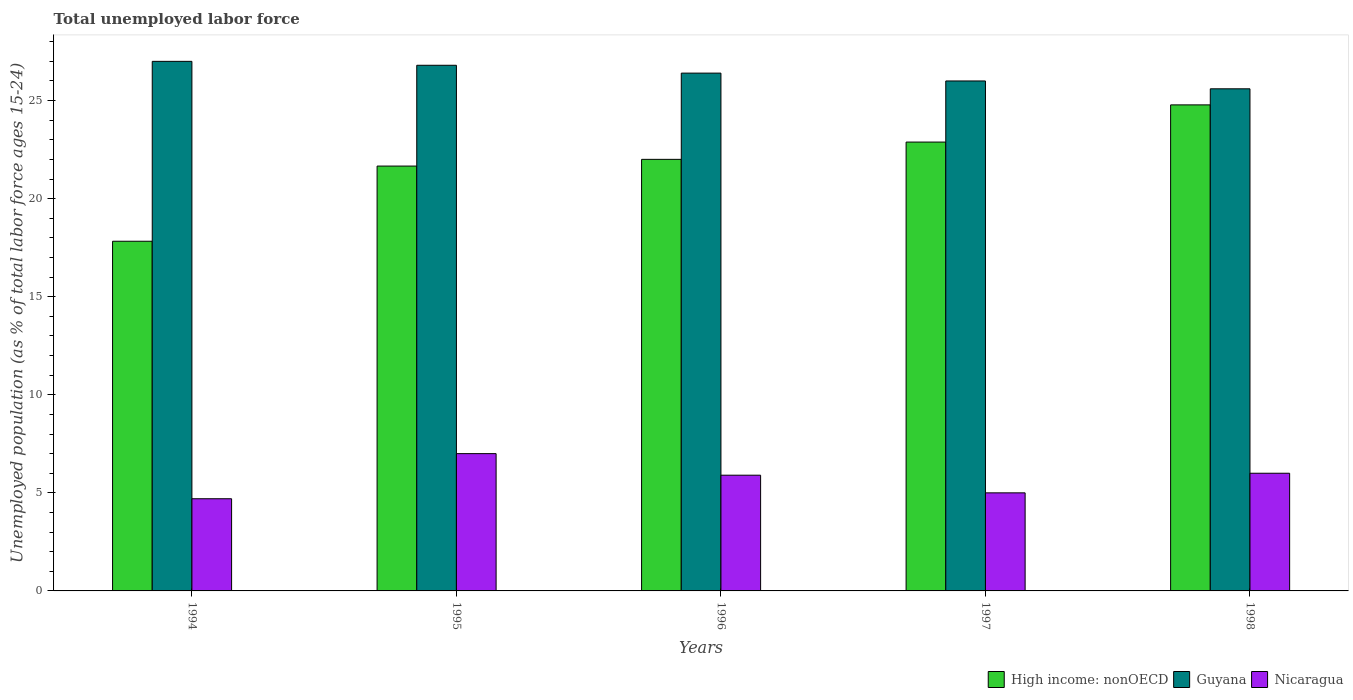How many different coloured bars are there?
Your response must be concise. 3. Are the number of bars per tick equal to the number of legend labels?
Keep it short and to the point. Yes. Are the number of bars on each tick of the X-axis equal?
Your answer should be very brief. Yes. How many bars are there on the 3rd tick from the left?
Your answer should be very brief. 3. In how many cases, is the number of bars for a given year not equal to the number of legend labels?
Offer a terse response. 0. What is the percentage of unemployed population in in High income: nonOECD in 1996?
Your answer should be compact. 22. Across all years, what is the maximum percentage of unemployed population in in High income: nonOECD?
Offer a terse response. 24.78. Across all years, what is the minimum percentage of unemployed population in in High income: nonOECD?
Make the answer very short. 17.83. In which year was the percentage of unemployed population in in High income: nonOECD minimum?
Your response must be concise. 1994. What is the total percentage of unemployed population in in Nicaragua in the graph?
Your answer should be compact. 28.6. What is the difference between the percentage of unemployed population in in High income: nonOECD in 1995 and that in 1998?
Offer a terse response. -3.12. What is the difference between the percentage of unemployed population in in High income: nonOECD in 1998 and the percentage of unemployed population in in Guyana in 1996?
Offer a very short reply. -1.62. What is the average percentage of unemployed population in in High income: nonOECD per year?
Provide a succinct answer. 21.83. In the year 1998, what is the difference between the percentage of unemployed population in in Guyana and percentage of unemployed population in in Nicaragua?
Your answer should be compact. 19.6. What is the ratio of the percentage of unemployed population in in Guyana in 1994 to that in 1998?
Your answer should be very brief. 1.05. What is the difference between the highest and the second highest percentage of unemployed population in in Guyana?
Make the answer very short. 0.2. What is the difference between the highest and the lowest percentage of unemployed population in in Guyana?
Offer a very short reply. 1.4. Is the sum of the percentage of unemployed population in in Guyana in 1994 and 1996 greater than the maximum percentage of unemployed population in in Nicaragua across all years?
Offer a very short reply. Yes. What does the 3rd bar from the left in 1995 represents?
Provide a short and direct response. Nicaragua. What does the 2nd bar from the right in 1995 represents?
Your answer should be compact. Guyana. How many bars are there?
Offer a very short reply. 15. Are all the bars in the graph horizontal?
Give a very brief answer. No. What is the difference between two consecutive major ticks on the Y-axis?
Provide a short and direct response. 5. Are the values on the major ticks of Y-axis written in scientific E-notation?
Keep it short and to the point. No. Does the graph contain any zero values?
Your answer should be very brief. No. Does the graph contain grids?
Offer a terse response. No. Where does the legend appear in the graph?
Keep it short and to the point. Bottom right. How many legend labels are there?
Your answer should be compact. 3. How are the legend labels stacked?
Ensure brevity in your answer.  Horizontal. What is the title of the graph?
Provide a succinct answer. Total unemployed labor force. Does "Grenada" appear as one of the legend labels in the graph?
Your answer should be compact. No. What is the label or title of the Y-axis?
Ensure brevity in your answer.  Unemployed population (as % of total labor force ages 15-24). What is the Unemployed population (as % of total labor force ages 15-24) of High income: nonOECD in 1994?
Offer a terse response. 17.83. What is the Unemployed population (as % of total labor force ages 15-24) of Guyana in 1994?
Provide a short and direct response. 27. What is the Unemployed population (as % of total labor force ages 15-24) of Nicaragua in 1994?
Your answer should be very brief. 4.7. What is the Unemployed population (as % of total labor force ages 15-24) of High income: nonOECD in 1995?
Your answer should be very brief. 21.66. What is the Unemployed population (as % of total labor force ages 15-24) of Guyana in 1995?
Your response must be concise. 26.8. What is the Unemployed population (as % of total labor force ages 15-24) of Nicaragua in 1995?
Provide a short and direct response. 7. What is the Unemployed population (as % of total labor force ages 15-24) in High income: nonOECD in 1996?
Your answer should be very brief. 22. What is the Unemployed population (as % of total labor force ages 15-24) in Guyana in 1996?
Ensure brevity in your answer.  26.4. What is the Unemployed population (as % of total labor force ages 15-24) in Nicaragua in 1996?
Your answer should be compact. 5.9. What is the Unemployed population (as % of total labor force ages 15-24) of High income: nonOECD in 1997?
Give a very brief answer. 22.88. What is the Unemployed population (as % of total labor force ages 15-24) in High income: nonOECD in 1998?
Your answer should be compact. 24.78. What is the Unemployed population (as % of total labor force ages 15-24) of Guyana in 1998?
Ensure brevity in your answer.  25.6. What is the Unemployed population (as % of total labor force ages 15-24) in Nicaragua in 1998?
Provide a succinct answer. 6. Across all years, what is the maximum Unemployed population (as % of total labor force ages 15-24) of High income: nonOECD?
Your answer should be compact. 24.78. Across all years, what is the maximum Unemployed population (as % of total labor force ages 15-24) in Guyana?
Keep it short and to the point. 27. Across all years, what is the minimum Unemployed population (as % of total labor force ages 15-24) in High income: nonOECD?
Ensure brevity in your answer.  17.83. Across all years, what is the minimum Unemployed population (as % of total labor force ages 15-24) of Guyana?
Give a very brief answer. 25.6. Across all years, what is the minimum Unemployed population (as % of total labor force ages 15-24) of Nicaragua?
Your response must be concise. 4.7. What is the total Unemployed population (as % of total labor force ages 15-24) of High income: nonOECD in the graph?
Ensure brevity in your answer.  109.16. What is the total Unemployed population (as % of total labor force ages 15-24) of Guyana in the graph?
Provide a succinct answer. 131.8. What is the total Unemployed population (as % of total labor force ages 15-24) in Nicaragua in the graph?
Provide a short and direct response. 28.6. What is the difference between the Unemployed population (as % of total labor force ages 15-24) in High income: nonOECD in 1994 and that in 1995?
Your answer should be compact. -3.83. What is the difference between the Unemployed population (as % of total labor force ages 15-24) of High income: nonOECD in 1994 and that in 1996?
Offer a very short reply. -4.17. What is the difference between the Unemployed population (as % of total labor force ages 15-24) of High income: nonOECD in 1994 and that in 1997?
Offer a very short reply. -5.06. What is the difference between the Unemployed population (as % of total labor force ages 15-24) of Guyana in 1994 and that in 1997?
Provide a succinct answer. 1. What is the difference between the Unemployed population (as % of total labor force ages 15-24) of High income: nonOECD in 1994 and that in 1998?
Keep it short and to the point. -6.95. What is the difference between the Unemployed population (as % of total labor force ages 15-24) in High income: nonOECD in 1995 and that in 1996?
Keep it short and to the point. -0.34. What is the difference between the Unemployed population (as % of total labor force ages 15-24) of High income: nonOECD in 1995 and that in 1997?
Your answer should be very brief. -1.22. What is the difference between the Unemployed population (as % of total labor force ages 15-24) in Nicaragua in 1995 and that in 1997?
Your answer should be compact. 2. What is the difference between the Unemployed population (as % of total labor force ages 15-24) in High income: nonOECD in 1995 and that in 1998?
Your answer should be compact. -3.12. What is the difference between the Unemployed population (as % of total labor force ages 15-24) in Guyana in 1995 and that in 1998?
Offer a very short reply. 1.2. What is the difference between the Unemployed population (as % of total labor force ages 15-24) in Nicaragua in 1995 and that in 1998?
Your answer should be very brief. 1. What is the difference between the Unemployed population (as % of total labor force ages 15-24) in High income: nonOECD in 1996 and that in 1997?
Make the answer very short. -0.88. What is the difference between the Unemployed population (as % of total labor force ages 15-24) in Guyana in 1996 and that in 1997?
Your answer should be very brief. 0.4. What is the difference between the Unemployed population (as % of total labor force ages 15-24) in Nicaragua in 1996 and that in 1997?
Ensure brevity in your answer.  0.9. What is the difference between the Unemployed population (as % of total labor force ages 15-24) in High income: nonOECD in 1996 and that in 1998?
Give a very brief answer. -2.78. What is the difference between the Unemployed population (as % of total labor force ages 15-24) in Nicaragua in 1996 and that in 1998?
Provide a short and direct response. -0.1. What is the difference between the Unemployed population (as % of total labor force ages 15-24) of High income: nonOECD in 1997 and that in 1998?
Your answer should be very brief. -1.9. What is the difference between the Unemployed population (as % of total labor force ages 15-24) of Guyana in 1997 and that in 1998?
Offer a very short reply. 0.4. What is the difference between the Unemployed population (as % of total labor force ages 15-24) of Nicaragua in 1997 and that in 1998?
Offer a very short reply. -1. What is the difference between the Unemployed population (as % of total labor force ages 15-24) of High income: nonOECD in 1994 and the Unemployed population (as % of total labor force ages 15-24) of Guyana in 1995?
Offer a terse response. -8.97. What is the difference between the Unemployed population (as % of total labor force ages 15-24) of High income: nonOECD in 1994 and the Unemployed population (as % of total labor force ages 15-24) of Nicaragua in 1995?
Provide a short and direct response. 10.83. What is the difference between the Unemployed population (as % of total labor force ages 15-24) of High income: nonOECD in 1994 and the Unemployed population (as % of total labor force ages 15-24) of Guyana in 1996?
Give a very brief answer. -8.57. What is the difference between the Unemployed population (as % of total labor force ages 15-24) in High income: nonOECD in 1994 and the Unemployed population (as % of total labor force ages 15-24) in Nicaragua in 1996?
Your answer should be very brief. 11.93. What is the difference between the Unemployed population (as % of total labor force ages 15-24) in Guyana in 1994 and the Unemployed population (as % of total labor force ages 15-24) in Nicaragua in 1996?
Your answer should be very brief. 21.1. What is the difference between the Unemployed population (as % of total labor force ages 15-24) of High income: nonOECD in 1994 and the Unemployed population (as % of total labor force ages 15-24) of Guyana in 1997?
Offer a very short reply. -8.17. What is the difference between the Unemployed population (as % of total labor force ages 15-24) in High income: nonOECD in 1994 and the Unemployed population (as % of total labor force ages 15-24) in Nicaragua in 1997?
Ensure brevity in your answer.  12.83. What is the difference between the Unemployed population (as % of total labor force ages 15-24) in Guyana in 1994 and the Unemployed population (as % of total labor force ages 15-24) in Nicaragua in 1997?
Provide a succinct answer. 22. What is the difference between the Unemployed population (as % of total labor force ages 15-24) of High income: nonOECD in 1994 and the Unemployed population (as % of total labor force ages 15-24) of Guyana in 1998?
Give a very brief answer. -7.77. What is the difference between the Unemployed population (as % of total labor force ages 15-24) of High income: nonOECD in 1994 and the Unemployed population (as % of total labor force ages 15-24) of Nicaragua in 1998?
Offer a terse response. 11.83. What is the difference between the Unemployed population (as % of total labor force ages 15-24) in Guyana in 1994 and the Unemployed population (as % of total labor force ages 15-24) in Nicaragua in 1998?
Offer a terse response. 21. What is the difference between the Unemployed population (as % of total labor force ages 15-24) in High income: nonOECD in 1995 and the Unemployed population (as % of total labor force ages 15-24) in Guyana in 1996?
Offer a terse response. -4.74. What is the difference between the Unemployed population (as % of total labor force ages 15-24) in High income: nonOECD in 1995 and the Unemployed population (as % of total labor force ages 15-24) in Nicaragua in 1996?
Your answer should be compact. 15.76. What is the difference between the Unemployed population (as % of total labor force ages 15-24) of Guyana in 1995 and the Unemployed population (as % of total labor force ages 15-24) of Nicaragua in 1996?
Offer a very short reply. 20.9. What is the difference between the Unemployed population (as % of total labor force ages 15-24) of High income: nonOECD in 1995 and the Unemployed population (as % of total labor force ages 15-24) of Guyana in 1997?
Your answer should be very brief. -4.34. What is the difference between the Unemployed population (as % of total labor force ages 15-24) of High income: nonOECD in 1995 and the Unemployed population (as % of total labor force ages 15-24) of Nicaragua in 1997?
Provide a succinct answer. 16.66. What is the difference between the Unemployed population (as % of total labor force ages 15-24) in Guyana in 1995 and the Unemployed population (as % of total labor force ages 15-24) in Nicaragua in 1997?
Keep it short and to the point. 21.8. What is the difference between the Unemployed population (as % of total labor force ages 15-24) in High income: nonOECD in 1995 and the Unemployed population (as % of total labor force ages 15-24) in Guyana in 1998?
Your response must be concise. -3.94. What is the difference between the Unemployed population (as % of total labor force ages 15-24) of High income: nonOECD in 1995 and the Unemployed population (as % of total labor force ages 15-24) of Nicaragua in 1998?
Provide a succinct answer. 15.66. What is the difference between the Unemployed population (as % of total labor force ages 15-24) of Guyana in 1995 and the Unemployed population (as % of total labor force ages 15-24) of Nicaragua in 1998?
Provide a short and direct response. 20.8. What is the difference between the Unemployed population (as % of total labor force ages 15-24) in High income: nonOECD in 1996 and the Unemployed population (as % of total labor force ages 15-24) in Guyana in 1997?
Your answer should be very brief. -4. What is the difference between the Unemployed population (as % of total labor force ages 15-24) in High income: nonOECD in 1996 and the Unemployed population (as % of total labor force ages 15-24) in Nicaragua in 1997?
Give a very brief answer. 17. What is the difference between the Unemployed population (as % of total labor force ages 15-24) in Guyana in 1996 and the Unemployed population (as % of total labor force ages 15-24) in Nicaragua in 1997?
Your answer should be very brief. 21.4. What is the difference between the Unemployed population (as % of total labor force ages 15-24) in High income: nonOECD in 1996 and the Unemployed population (as % of total labor force ages 15-24) in Guyana in 1998?
Your answer should be compact. -3.6. What is the difference between the Unemployed population (as % of total labor force ages 15-24) in High income: nonOECD in 1996 and the Unemployed population (as % of total labor force ages 15-24) in Nicaragua in 1998?
Offer a terse response. 16. What is the difference between the Unemployed population (as % of total labor force ages 15-24) in Guyana in 1996 and the Unemployed population (as % of total labor force ages 15-24) in Nicaragua in 1998?
Offer a terse response. 20.4. What is the difference between the Unemployed population (as % of total labor force ages 15-24) of High income: nonOECD in 1997 and the Unemployed population (as % of total labor force ages 15-24) of Guyana in 1998?
Your answer should be compact. -2.72. What is the difference between the Unemployed population (as % of total labor force ages 15-24) in High income: nonOECD in 1997 and the Unemployed population (as % of total labor force ages 15-24) in Nicaragua in 1998?
Keep it short and to the point. 16.88. What is the difference between the Unemployed population (as % of total labor force ages 15-24) in Guyana in 1997 and the Unemployed population (as % of total labor force ages 15-24) in Nicaragua in 1998?
Keep it short and to the point. 20. What is the average Unemployed population (as % of total labor force ages 15-24) of High income: nonOECD per year?
Your answer should be very brief. 21.83. What is the average Unemployed population (as % of total labor force ages 15-24) of Guyana per year?
Offer a very short reply. 26.36. What is the average Unemployed population (as % of total labor force ages 15-24) of Nicaragua per year?
Provide a succinct answer. 5.72. In the year 1994, what is the difference between the Unemployed population (as % of total labor force ages 15-24) in High income: nonOECD and Unemployed population (as % of total labor force ages 15-24) in Guyana?
Offer a terse response. -9.17. In the year 1994, what is the difference between the Unemployed population (as % of total labor force ages 15-24) in High income: nonOECD and Unemployed population (as % of total labor force ages 15-24) in Nicaragua?
Offer a very short reply. 13.13. In the year 1994, what is the difference between the Unemployed population (as % of total labor force ages 15-24) in Guyana and Unemployed population (as % of total labor force ages 15-24) in Nicaragua?
Make the answer very short. 22.3. In the year 1995, what is the difference between the Unemployed population (as % of total labor force ages 15-24) in High income: nonOECD and Unemployed population (as % of total labor force ages 15-24) in Guyana?
Your answer should be very brief. -5.14. In the year 1995, what is the difference between the Unemployed population (as % of total labor force ages 15-24) of High income: nonOECD and Unemployed population (as % of total labor force ages 15-24) of Nicaragua?
Provide a succinct answer. 14.66. In the year 1995, what is the difference between the Unemployed population (as % of total labor force ages 15-24) in Guyana and Unemployed population (as % of total labor force ages 15-24) in Nicaragua?
Your response must be concise. 19.8. In the year 1996, what is the difference between the Unemployed population (as % of total labor force ages 15-24) in High income: nonOECD and Unemployed population (as % of total labor force ages 15-24) in Guyana?
Your response must be concise. -4.4. In the year 1996, what is the difference between the Unemployed population (as % of total labor force ages 15-24) of High income: nonOECD and Unemployed population (as % of total labor force ages 15-24) of Nicaragua?
Give a very brief answer. 16.1. In the year 1997, what is the difference between the Unemployed population (as % of total labor force ages 15-24) in High income: nonOECD and Unemployed population (as % of total labor force ages 15-24) in Guyana?
Your answer should be very brief. -3.12. In the year 1997, what is the difference between the Unemployed population (as % of total labor force ages 15-24) of High income: nonOECD and Unemployed population (as % of total labor force ages 15-24) of Nicaragua?
Offer a terse response. 17.88. In the year 1997, what is the difference between the Unemployed population (as % of total labor force ages 15-24) in Guyana and Unemployed population (as % of total labor force ages 15-24) in Nicaragua?
Provide a succinct answer. 21. In the year 1998, what is the difference between the Unemployed population (as % of total labor force ages 15-24) in High income: nonOECD and Unemployed population (as % of total labor force ages 15-24) in Guyana?
Keep it short and to the point. -0.82. In the year 1998, what is the difference between the Unemployed population (as % of total labor force ages 15-24) in High income: nonOECD and Unemployed population (as % of total labor force ages 15-24) in Nicaragua?
Offer a terse response. 18.78. In the year 1998, what is the difference between the Unemployed population (as % of total labor force ages 15-24) of Guyana and Unemployed population (as % of total labor force ages 15-24) of Nicaragua?
Your response must be concise. 19.6. What is the ratio of the Unemployed population (as % of total labor force ages 15-24) of High income: nonOECD in 1994 to that in 1995?
Provide a succinct answer. 0.82. What is the ratio of the Unemployed population (as % of total labor force ages 15-24) of Guyana in 1994 to that in 1995?
Offer a terse response. 1.01. What is the ratio of the Unemployed population (as % of total labor force ages 15-24) in Nicaragua in 1994 to that in 1995?
Your response must be concise. 0.67. What is the ratio of the Unemployed population (as % of total labor force ages 15-24) of High income: nonOECD in 1994 to that in 1996?
Your answer should be very brief. 0.81. What is the ratio of the Unemployed population (as % of total labor force ages 15-24) in Guyana in 1994 to that in 1996?
Provide a succinct answer. 1.02. What is the ratio of the Unemployed population (as % of total labor force ages 15-24) in Nicaragua in 1994 to that in 1996?
Ensure brevity in your answer.  0.8. What is the ratio of the Unemployed population (as % of total labor force ages 15-24) in High income: nonOECD in 1994 to that in 1997?
Provide a short and direct response. 0.78. What is the ratio of the Unemployed population (as % of total labor force ages 15-24) in High income: nonOECD in 1994 to that in 1998?
Provide a succinct answer. 0.72. What is the ratio of the Unemployed population (as % of total labor force ages 15-24) in Guyana in 1994 to that in 1998?
Offer a very short reply. 1.05. What is the ratio of the Unemployed population (as % of total labor force ages 15-24) of Nicaragua in 1994 to that in 1998?
Provide a succinct answer. 0.78. What is the ratio of the Unemployed population (as % of total labor force ages 15-24) of High income: nonOECD in 1995 to that in 1996?
Provide a succinct answer. 0.98. What is the ratio of the Unemployed population (as % of total labor force ages 15-24) in Guyana in 1995 to that in 1996?
Ensure brevity in your answer.  1.02. What is the ratio of the Unemployed population (as % of total labor force ages 15-24) of Nicaragua in 1995 to that in 1996?
Make the answer very short. 1.19. What is the ratio of the Unemployed population (as % of total labor force ages 15-24) of High income: nonOECD in 1995 to that in 1997?
Your answer should be very brief. 0.95. What is the ratio of the Unemployed population (as % of total labor force ages 15-24) of Guyana in 1995 to that in 1997?
Your answer should be very brief. 1.03. What is the ratio of the Unemployed population (as % of total labor force ages 15-24) of High income: nonOECD in 1995 to that in 1998?
Ensure brevity in your answer.  0.87. What is the ratio of the Unemployed population (as % of total labor force ages 15-24) of Guyana in 1995 to that in 1998?
Give a very brief answer. 1.05. What is the ratio of the Unemployed population (as % of total labor force ages 15-24) of High income: nonOECD in 1996 to that in 1997?
Your answer should be compact. 0.96. What is the ratio of the Unemployed population (as % of total labor force ages 15-24) in Guyana in 1996 to that in 1997?
Provide a short and direct response. 1.02. What is the ratio of the Unemployed population (as % of total labor force ages 15-24) in Nicaragua in 1996 to that in 1997?
Offer a terse response. 1.18. What is the ratio of the Unemployed population (as % of total labor force ages 15-24) in High income: nonOECD in 1996 to that in 1998?
Provide a succinct answer. 0.89. What is the ratio of the Unemployed population (as % of total labor force ages 15-24) in Guyana in 1996 to that in 1998?
Offer a terse response. 1.03. What is the ratio of the Unemployed population (as % of total labor force ages 15-24) of Nicaragua in 1996 to that in 1998?
Provide a succinct answer. 0.98. What is the ratio of the Unemployed population (as % of total labor force ages 15-24) of High income: nonOECD in 1997 to that in 1998?
Keep it short and to the point. 0.92. What is the ratio of the Unemployed population (as % of total labor force ages 15-24) of Guyana in 1997 to that in 1998?
Ensure brevity in your answer.  1.02. What is the ratio of the Unemployed population (as % of total labor force ages 15-24) in Nicaragua in 1997 to that in 1998?
Your response must be concise. 0.83. What is the difference between the highest and the second highest Unemployed population (as % of total labor force ages 15-24) of High income: nonOECD?
Make the answer very short. 1.9. What is the difference between the highest and the second highest Unemployed population (as % of total labor force ages 15-24) in Guyana?
Offer a terse response. 0.2. What is the difference between the highest and the second highest Unemployed population (as % of total labor force ages 15-24) of Nicaragua?
Give a very brief answer. 1. What is the difference between the highest and the lowest Unemployed population (as % of total labor force ages 15-24) in High income: nonOECD?
Offer a very short reply. 6.95. What is the difference between the highest and the lowest Unemployed population (as % of total labor force ages 15-24) of Guyana?
Offer a terse response. 1.4. 